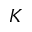Convert formula to latex. <formula><loc_0><loc_0><loc_500><loc_500>K</formula> 